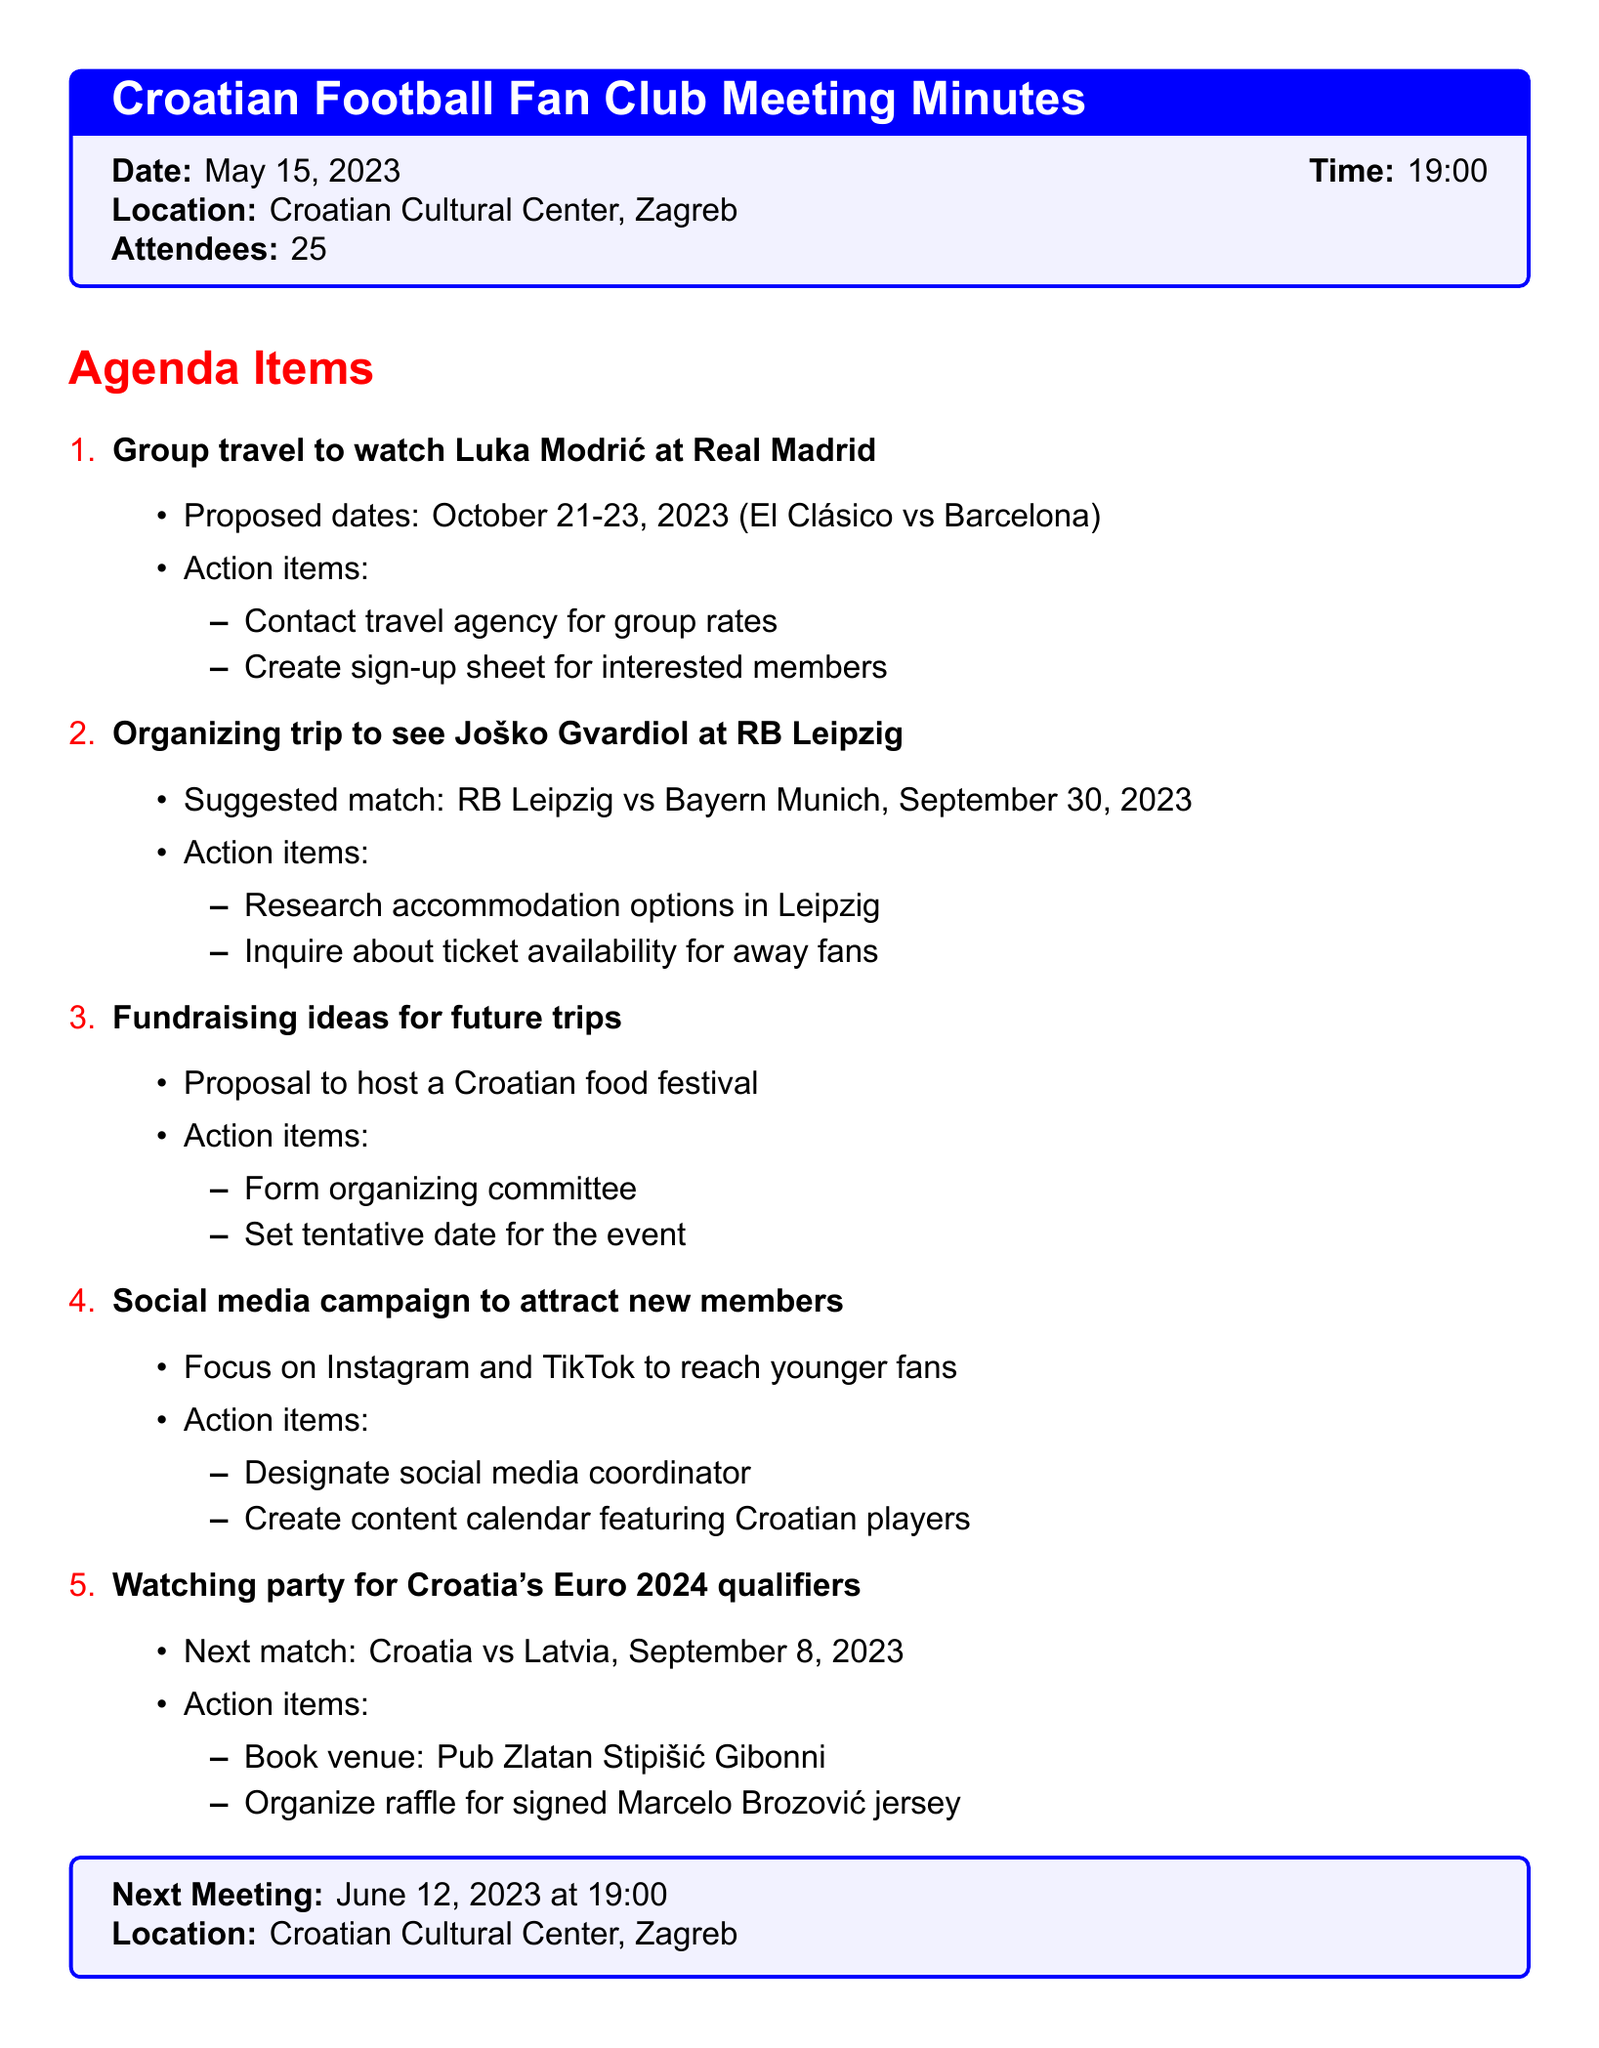what date is the meeting held? The meeting is scheduled on May 15, 2023.
Answer: May 15, 2023 how many attendees were present? The document mentions that there were 25 attendees at the meeting.
Answer: 25 who is the Croatian player to be watched at Real Madrid? The agenda item specifically mentions Luka Modrić as the player.
Answer: Luka Modrić what is the proposed date for the El Clásico match? The document states that the proposed dates are October 21-23, 2023.
Answer: October 21-23, 2023 which venue is booked for the watching party? The document specifies the venue as Pub Zlatan Stipišić Gibonni.
Answer: Pub Zlatan Stipišić Gibonni what action item is associated with the Croatian food festival? The action item calls for forming an organizing committee for the festival.
Answer: Form organizing committee how will new members be attracted? The document indicates a social media campaign focusing on Instagram and TikTok.
Answer: Instagram and TikTok what match is suggested for Joško Gvardiol at RB Leipzig? The match mentioned is RB Leipzig vs Bayern Munich on September 30, 2023.
Answer: RB Leipzig vs Bayern Munich when is the next meeting scheduled? The document lists the date for the next meeting as June 12, 2023.
Answer: June 12, 2023 